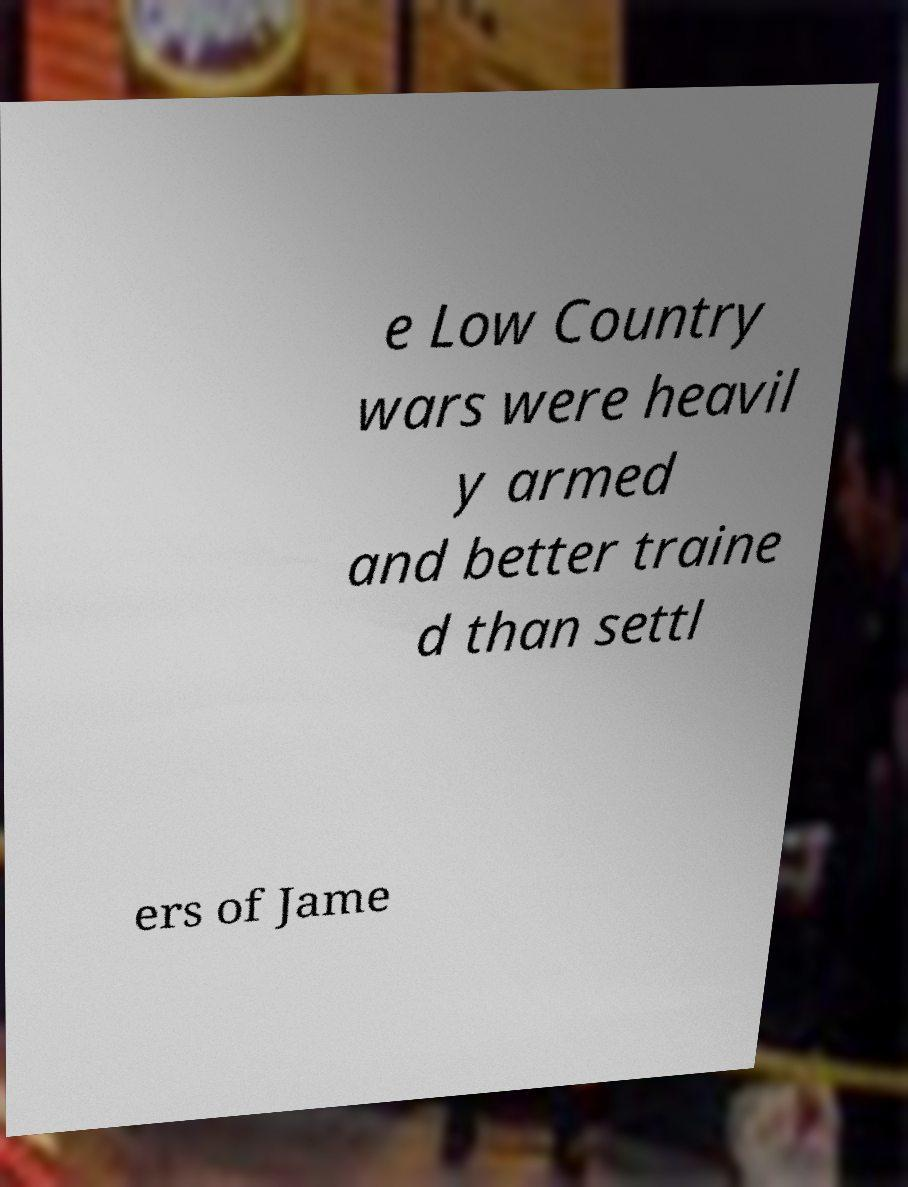There's text embedded in this image that I need extracted. Can you transcribe it verbatim? e Low Country wars were heavil y armed and better traine d than settl ers of Jame 